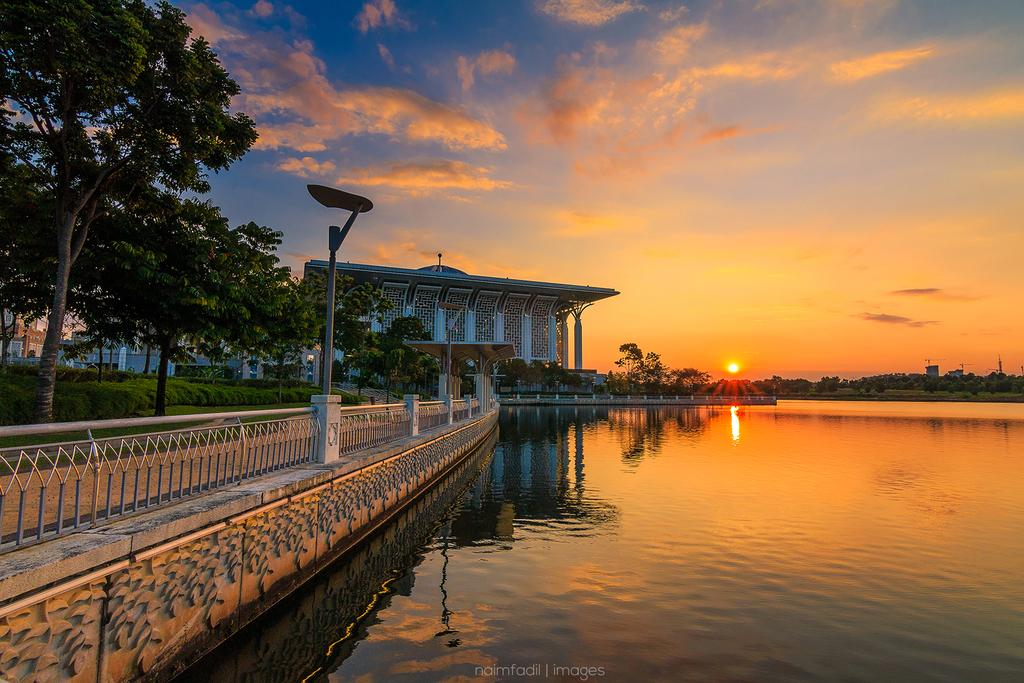What type of natural feature can be seen in the image? There is a lake in the image. What is located on the right side of the image? There is fencing on the right side of the image. What type of vegetation is present in the image? There are trees in the image. What structure can be seen in the background of the image? There is a house in the background of the image. What is the condition of the sky in the image? There is a beautiful sunset in the sky. Can you see a toothbrush being used by someone in the image? There is no toothbrush present in the image. Is there a trampoline visible in the image? There is no trampoline present in the image. 